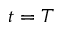Convert formula to latex. <formula><loc_0><loc_0><loc_500><loc_500>t = T</formula> 